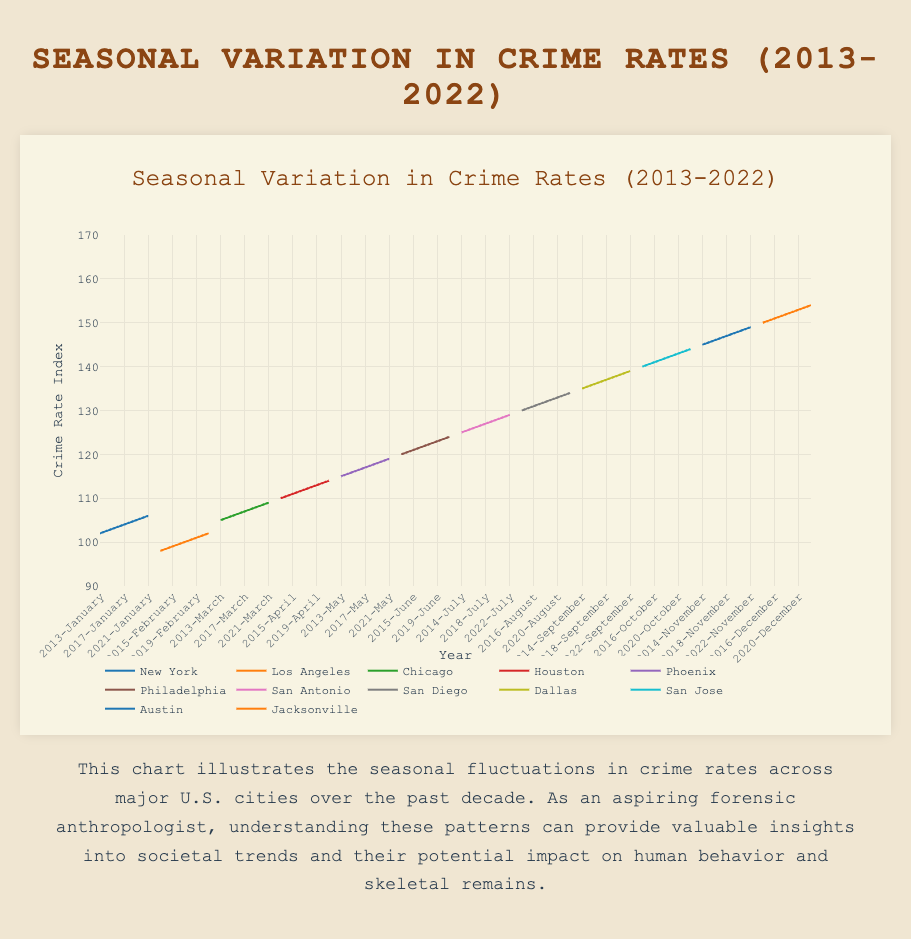Which city shows the highest crime rate index in December 2022? By looking at the end of the time series for December 2022, locate the highest point among the cities.
Answer: Jacksonville During what year did New York experience the highest crime rate index according to the plot? Follow the New York data points across the years and find the highest peak.
Answer: 2022 In which month does Los Angeles consistently have higher crime rates compared to January, and by how much on average? For each year, look at the crime rate index for Los Angeles in January and compare it with other months. Subtract January's value from each month and find the average of the positive differences.
Answer: July; 18 points Which city had a noticeable seasonal spike in crime rates during the summer months (June, July, August) over the past decade? Track the line graphs of each city during the summer months. Identify which city consistently shows a sharp rise.
Answer: Phoenix Compare crime rates between San Diego and Chicago in 2018. Which city had higher rates on average, and by how much? Calculate the average crime rate index for both cities in 2018 by summing the monthly values and dividing by the number of months. Subtract the averages to find the difference.
Answer: San Diego; 6 points Which city’s crime rate index showed the least variation over the entire period from 2013 to 2022? By examining the amplitude of the peaks and troughs in the plotted lines for all cities, identify the city with the smallest range.
Answer: New York What is the trend in crime rates in Austin over the 10-year period? Look at the slope of the line representing Austin over the decade.
Answer: Increasing In what year did Houston see a decrease in its crime rate index in November compared to October? Scan through the line representing Houston and compare the values of November and October for each year.
Answer: 2016 Does Philadelphia have any years where its highest monthly crime rate index was below 120? If so, specify the year(s). For each year, locate the peak value within Philadelphia's data. Check if any peak is below 120.
Answer: No What is the overall trend in crime rates in San Antonio from 2013 to 2022, and how does it compare to the trend in Dallas? Observe the direction of the lines representing both cities over time and compare their general trends.
Answer: Both increasing, but San Antonio's rise is steeper 